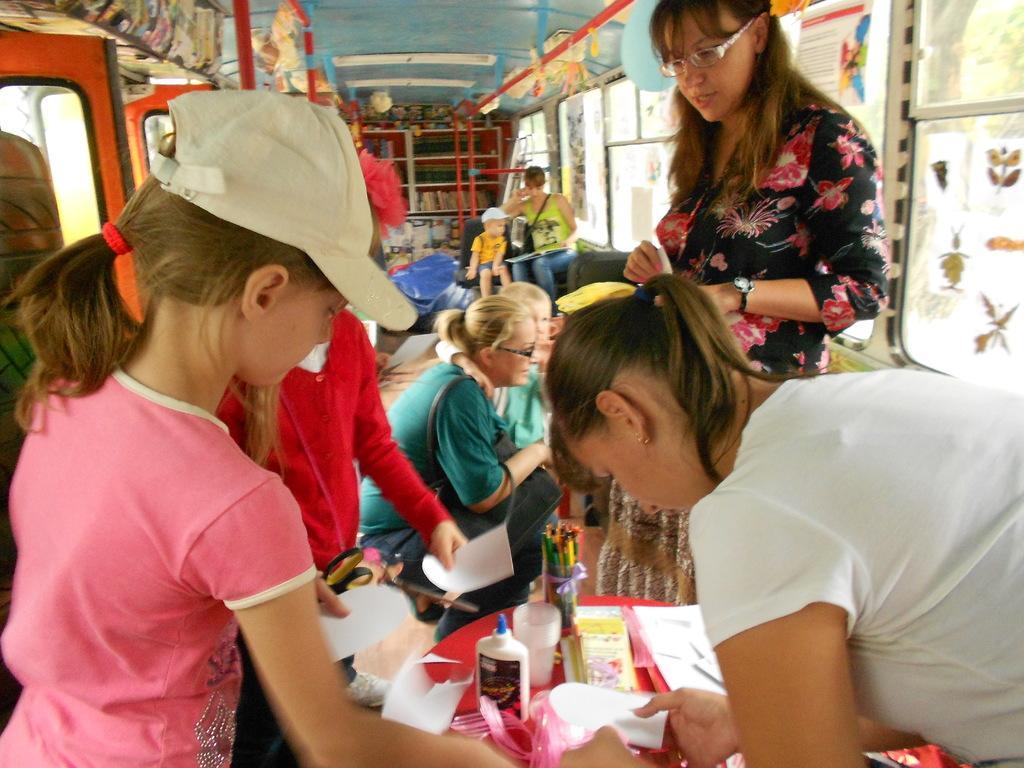In one or two sentences, can you explain what this image depicts? In the image we can see there are many people wearing clothes, some of them are wearing cap and goggles. This is a wristwatch, scissor, paper, glue, glass, color pencils, window, poster, pole and other objects. We can even see there are people sitting and some of them are standing. This is a floor and this is a table. 